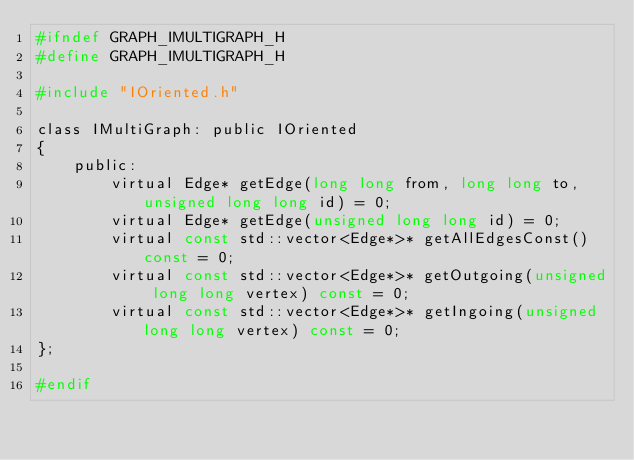<code> <loc_0><loc_0><loc_500><loc_500><_C_>#ifndef GRAPH_IMULTIGRAPH_H
#define GRAPH_IMULTIGRAPH_H

#include "IOriented.h"

class IMultiGraph: public IOriented
{
    public:
        virtual Edge* getEdge(long long from, long long to, unsigned long long id) = 0;
        virtual Edge* getEdge(unsigned long long id) = 0;
        virtual const std::vector<Edge*>* getAllEdgesConst() const = 0;
        virtual const std::vector<Edge*>* getOutgoing(unsigned long long vertex) const = 0;
        virtual const std::vector<Edge*>* getIngoing(unsigned long long vertex) const = 0;
};

#endif
</code> 